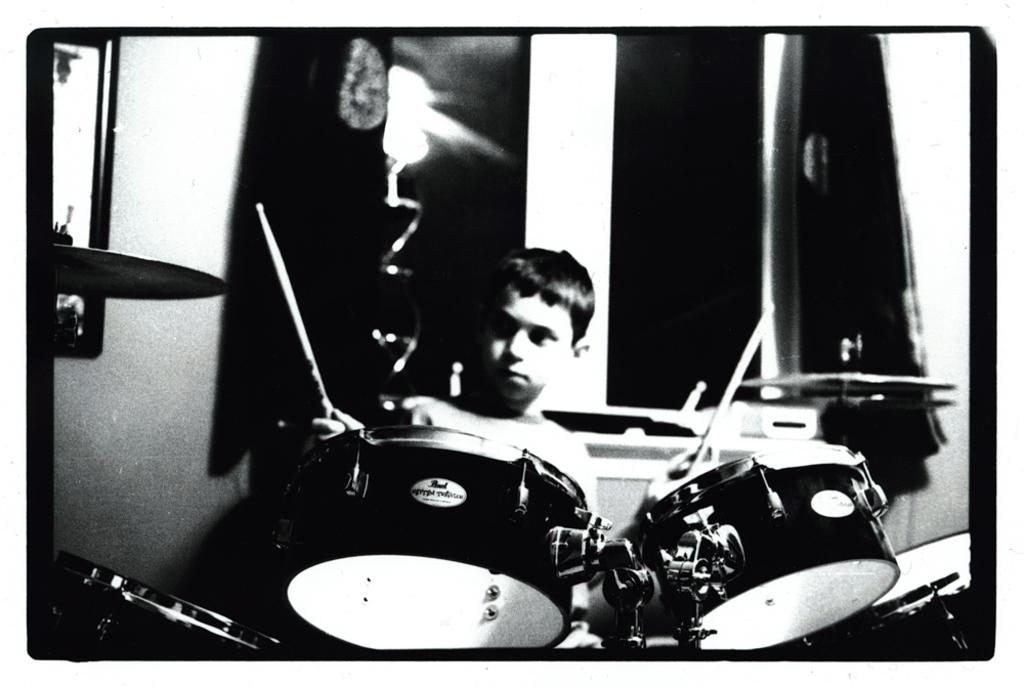What is the main subject of the image? There is a person playing a drum set in the image. What can be seen in the background of the image? There is a wall in the background of the image. What is the color scheme of the image? The image is black and white. What type of pail is being used by the committee in the image? There is no pail or committee present in the image; it features a person playing a drum set. What type of drum is being played by the person in the image? The image does not specify the type of drum being played, only that it is a drum set. 